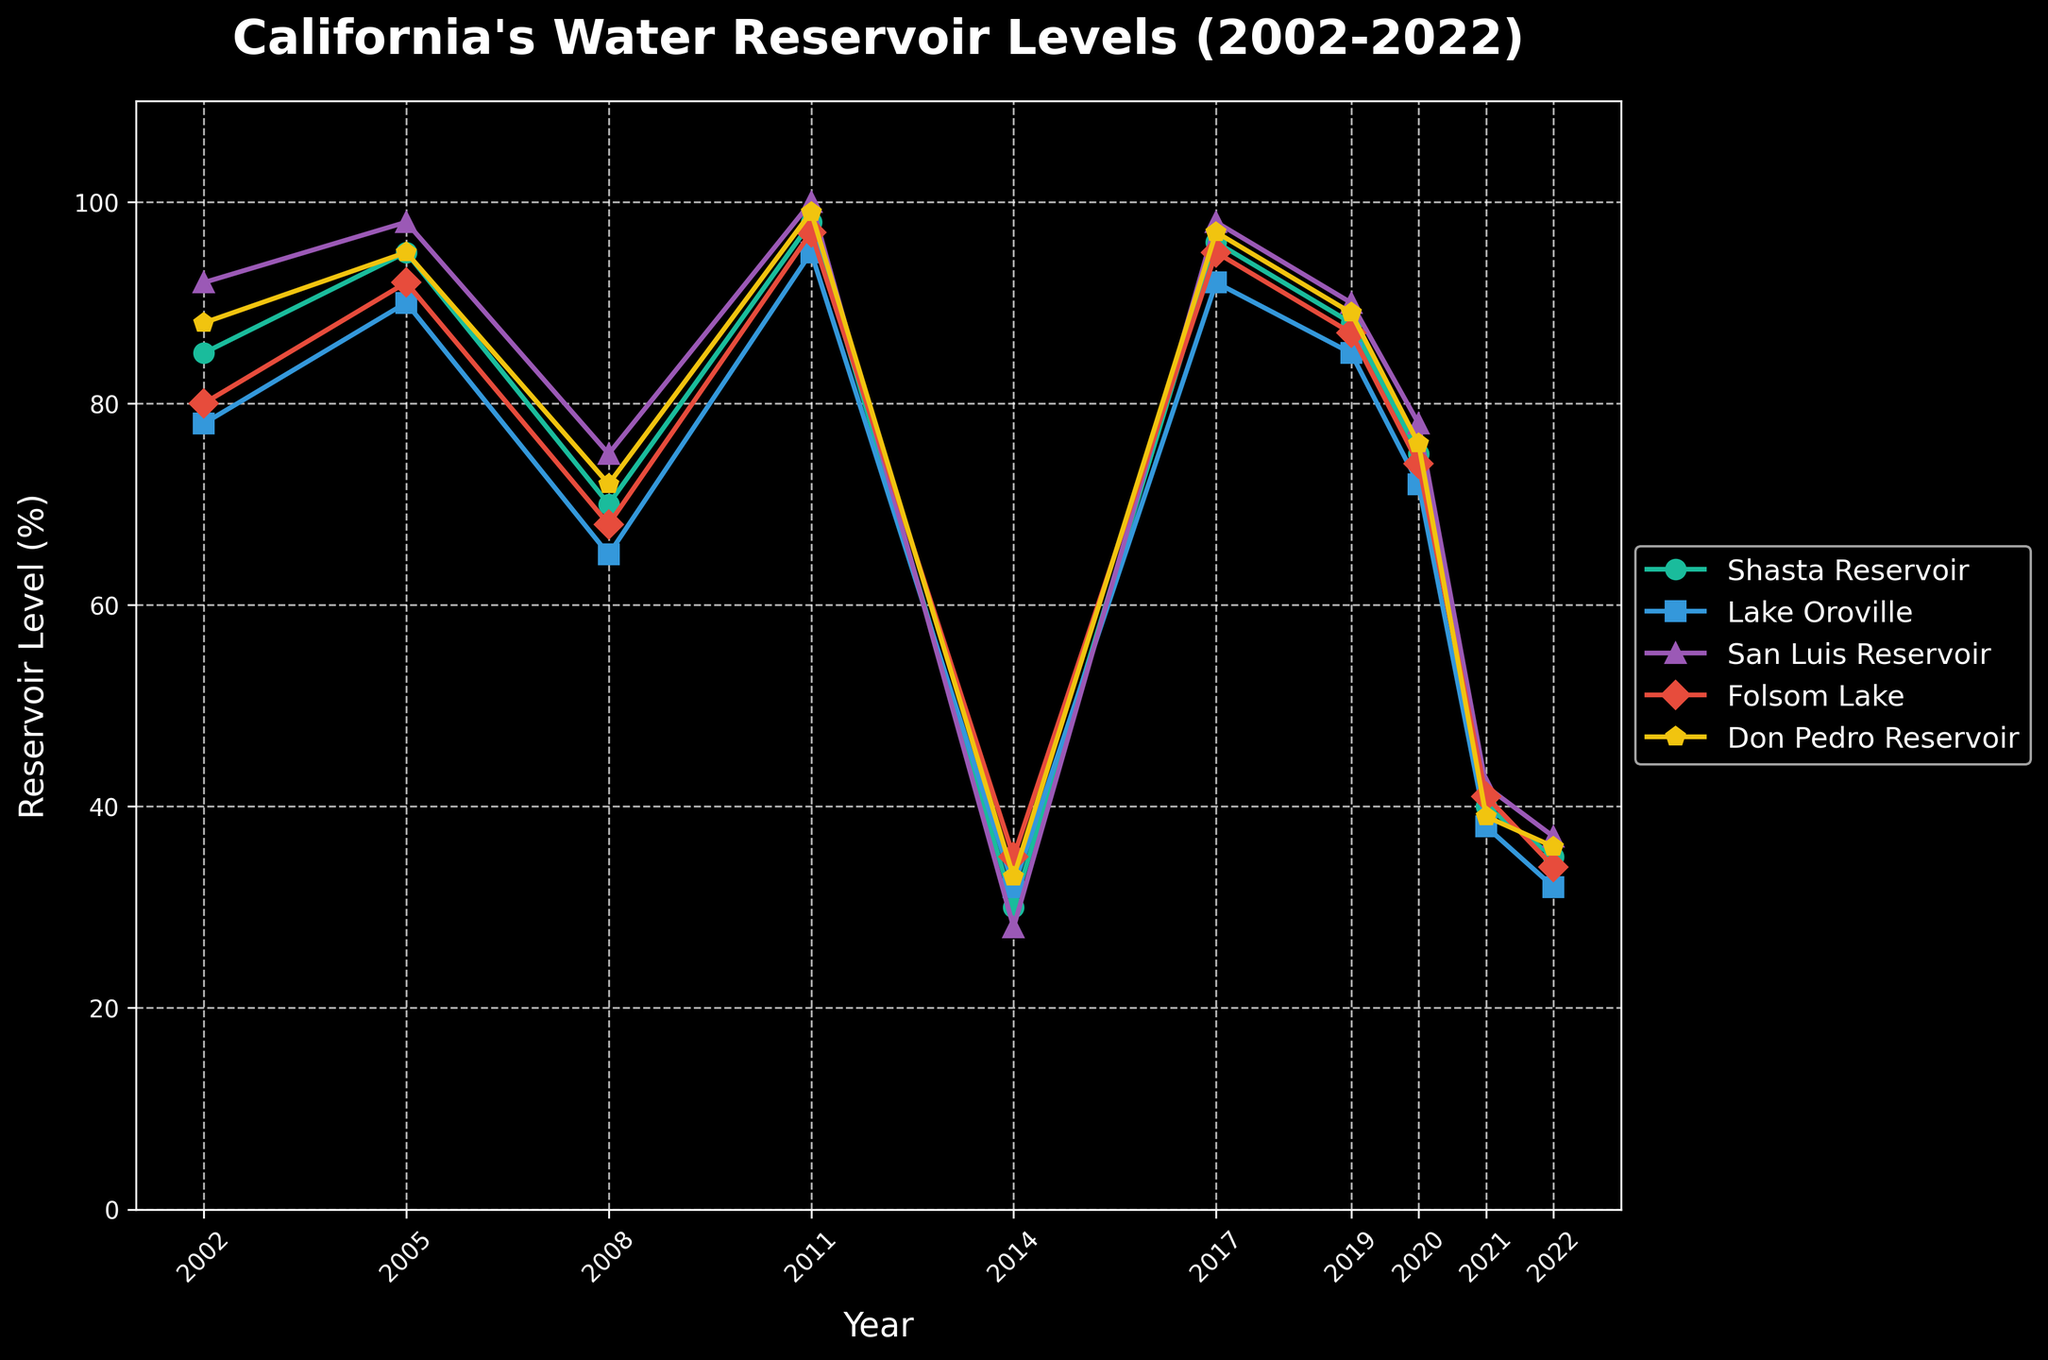What are the two years with the lowest levels for Shasta Reservoir? By observing the line chart, the lowest points for Shasta Reservoir can be identified by looking at the dips in its plotted line. These occur in 2014 and 2022.
Answer: 2014 and 2022 Which reservoir had the highest percentage level in 2011? In 2011, the plotted lines peak around 98%-100%, and by checking the colors/labels and corresponding points, we see that San Luis Reservoir reaches 100%.
Answer: San Luis Reservoir What is the difference in the level of Folsom Lake between 2005 and 2008? Locate the Folsom Lake line and identify the points for 2005 and 2008, which are 92% and 68%, respectively. The difference is 92 - 68 = 24%.
Answer: 24% Between 2014 and 2022, which reservoir experienced the most significant decrease? Comparing all reservoir levels from 2014 and 2022, we see the largest decrease in Shasta Reservoir, dropping from 30% to 35%, a decrease of 55%.
Answer: Shasta Reservoir What is the average reservoir level for Lake Oroville over the observed period? Adding the levels for Lake Oroville (78, 90, 65, 95, 32, 92, 85, 72, 38, 32) and dividing by 10 results in (78+90+65+95+32+92+85+72+38+32)/10 = 67.9.
Answer: 67.9 In which two years did Don Pedro Reservoir mirror the same level? By tracing the line for Don Pedro Reservoir, the identical points can be seen in 2014 and 2022, both marked at 33%.
Answer: 2014 and 2022 How do the drought and non-drought periods compare for Shasta Reservoir between 2011 and 2014, and 2017 and 2019? Shasta Reservoir drops from 98% in 2011 to 30% in 2014 during a drought, and peaks again from 96% in 2017 to 88% in 2019 during a non-drought period, showing significant fluctuation.
Answer: Drought drop: 68%, Non-drought drop: 8% Which year had the lowest average reservoir level across all reservoirs? Calculate the average for each year and compare: 2002 (84.6%), 2005 (94%), 2008 (70%), 2011 (97.8%), 2014 (31.6%), 2017 (95.6%), 2019 (87.8%), 2020 (75%), 2021 (40%), 2022 (34.8%). 2014 has the lowest average level.
Answer: 2014 Did the levels of San Luis Reservoir ever reach 100% in the observed period? Observing the line for San Luis Reservoir, it reaches 100% in the year 2011.
Answer: Yes During which periods were levels for Folsom Lake highest and lowest? The highest was in 2011 at 97%. The lowest was in 2014 at 35%. These are determined by analyzing the highest and lowest points on the Folsom Lake line.
Answer: Highest: 2011, Lowest: 2014 